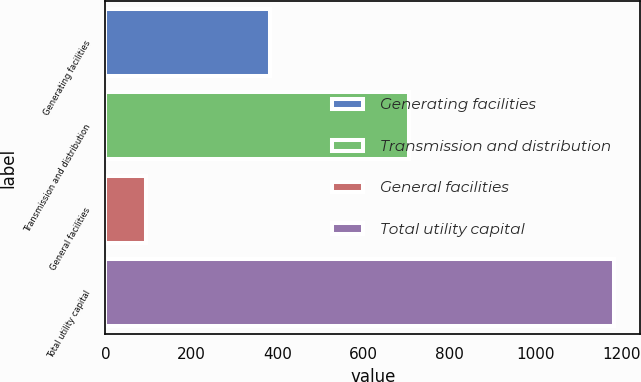Convert chart to OTSL. <chart><loc_0><loc_0><loc_500><loc_500><bar_chart><fcel>Generating facilities<fcel>Transmission and distribution<fcel>General facilities<fcel>Total utility capital<nl><fcel>383<fcel>706<fcel>94<fcel>1183<nl></chart> 